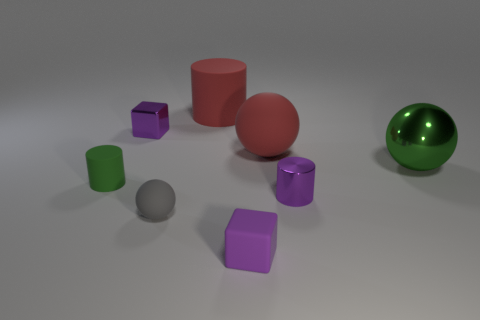Subtract all big red matte cylinders. How many cylinders are left? 2 Subtract all balls. How many objects are left? 5 Subtract 2 cylinders. How many cylinders are left? 1 Add 1 green metal balls. How many objects exist? 9 Subtract 2 purple blocks. How many objects are left? 6 Subtract all yellow cubes. Subtract all gray cylinders. How many cubes are left? 2 Subtract all brown cylinders. How many red balls are left? 1 Subtract all matte objects. Subtract all purple things. How many objects are left? 0 Add 2 green metal things. How many green metal things are left? 3 Add 7 brown matte cubes. How many brown matte cubes exist? 7 